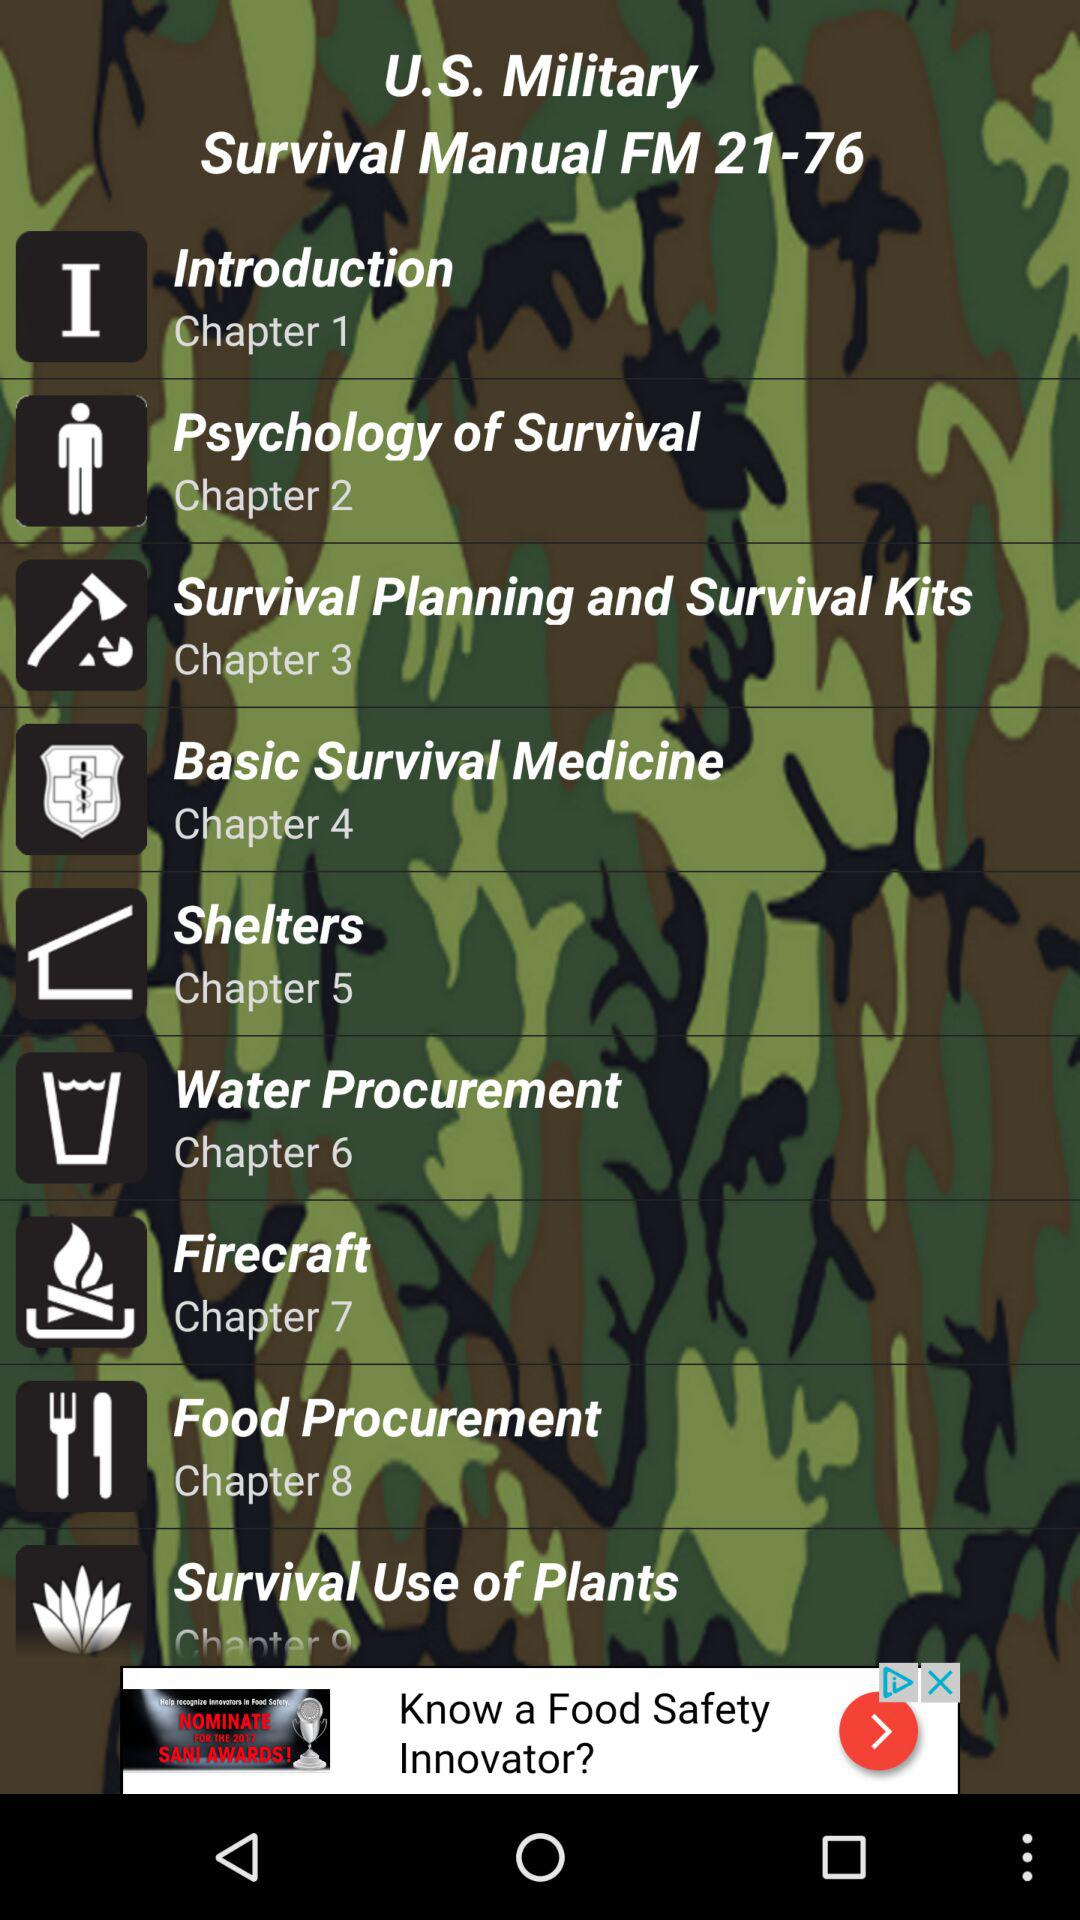How many chapters are about survival medicine?
Answer the question using a single word or phrase. 1 